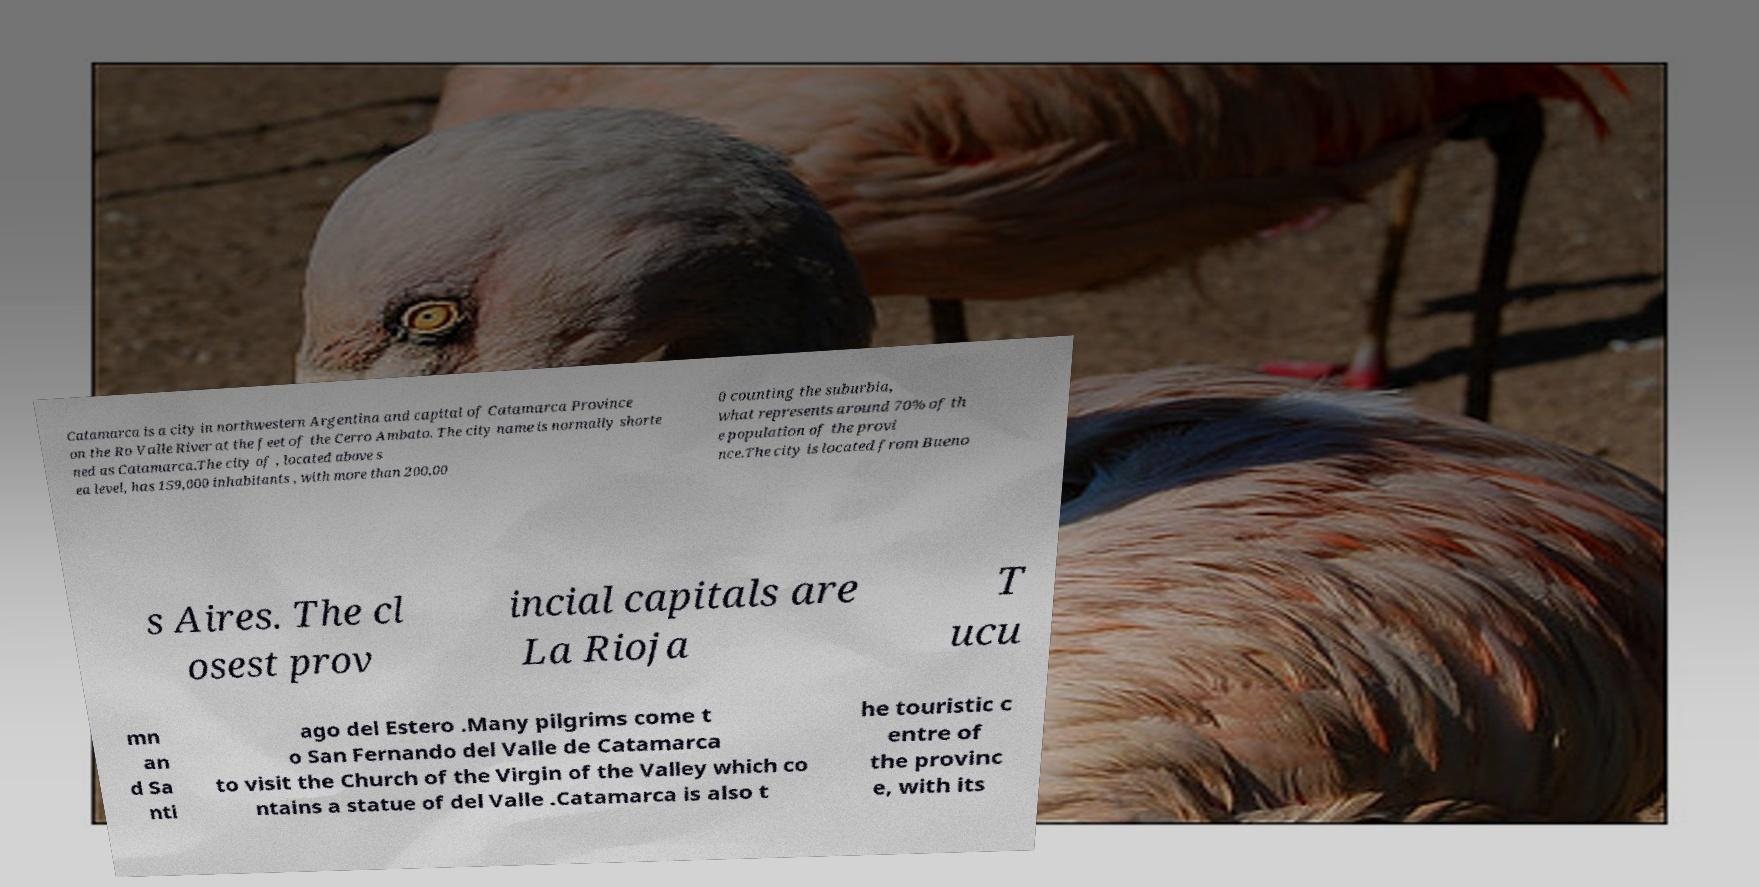Could you extract and type out the text from this image? Catamarca is a city in northwestern Argentina and capital of Catamarca Province on the Ro Valle River at the feet of the Cerro Ambato. The city name is normally shorte ned as Catamarca.The city of , located above s ea level, has 159,000 inhabitants , with more than 200,00 0 counting the suburbia, what represents around 70% of th e population of the provi nce.The city is located from Bueno s Aires. The cl osest prov incial capitals are La Rioja T ucu mn an d Sa nti ago del Estero .Many pilgrims come t o San Fernando del Valle de Catamarca to visit the Church of the Virgin of the Valley which co ntains a statue of del Valle .Catamarca is also t he touristic c entre of the provinc e, with its 